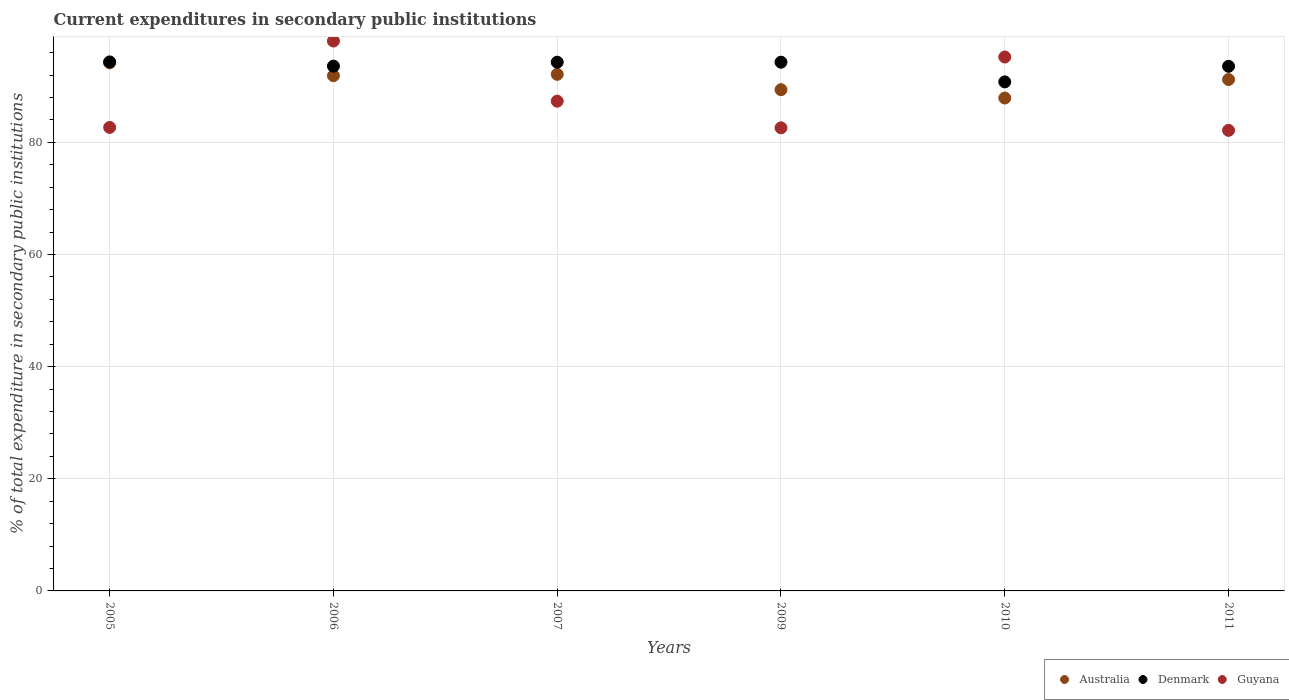How many different coloured dotlines are there?
Ensure brevity in your answer.  3. What is the current expenditures in secondary public institutions in Guyana in 2006?
Your response must be concise. 98.07. Across all years, what is the maximum current expenditures in secondary public institutions in Australia?
Offer a very short reply. 94.19. Across all years, what is the minimum current expenditures in secondary public institutions in Denmark?
Offer a very short reply. 90.79. In which year was the current expenditures in secondary public institutions in Guyana minimum?
Ensure brevity in your answer.  2011. What is the total current expenditures in secondary public institutions in Denmark in the graph?
Provide a short and direct response. 560.88. What is the difference between the current expenditures in secondary public institutions in Guyana in 2005 and that in 2007?
Give a very brief answer. -4.68. What is the difference between the current expenditures in secondary public institutions in Australia in 2007 and the current expenditures in secondary public institutions in Guyana in 2010?
Your response must be concise. -3.09. What is the average current expenditures in secondary public institutions in Guyana per year?
Keep it short and to the point. 88. In the year 2006, what is the difference between the current expenditures in secondary public institutions in Australia and current expenditures in secondary public institutions in Guyana?
Keep it short and to the point. -6.18. What is the ratio of the current expenditures in secondary public institutions in Australia in 2005 to that in 2010?
Offer a terse response. 1.07. Is the difference between the current expenditures in secondary public institutions in Australia in 2005 and 2011 greater than the difference between the current expenditures in secondary public institutions in Guyana in 2005 and 2011?
Provide a succinct answer. Yes. What is the difference between the highest and the second highest current expenditures in secondary public institutions in Guyana?
Ensure brevity in your answer.  2.85. What is the difference between the highest and the lowest current expenditures in secondary public institutions in Australia?
Your answer should be compact. 6.29. In how many years, is the current expenditures in secondary public institutions in Guyana greater than the average current expenditures in secondary public institutions in Guyana taken over all years?
Your answer should be compact. 2. Does the current expenditures in secondary public institutions in Australia monotonically increase over the years?
Keep it short and to the point. No. Is the current expenditures in secondary public institutions in Australia strictly greater than the current expenditures in secondary public institutions in Denmark over the years?
Ensure brevity in your answer.  No. How many years are there in the graph?
Give a very brief answer. 6. What is the difference between two consecutive major ticks on the Y-axis?
Provide a short and direct response. 20. Does the graph contain any zero values?
Ensure brevity in your answer.  No. What is the title of the graph?
Offer a very short reply. Current expenditures in secondary public institutions. Does "Middle East & North Africa (developing only)" appear as one of the legend labels in the graph?
Offer a terse response. No. What is the label or title of the Y-axis?
Your answer should be very brief. % of total expenditure in secondary public institutions. What is the % of total expenditure in secondary public institutions of Australia in 2005?
Provide a succinct answer. 94.19. What is the % of total expenditure in secondary public institutions of Denmark in 2005?
Provide a succinct answer. 94.35. What is the % of total expenditure in secondary public institutions of Guyana in 2005?
Offer a very short reply. 82.66. What is the % of total expenditure in secondary public institutions of Australia in 2006?
Your response must be concise. 91.89. What is the % of total expenditure in secondary public institutions of Denmark in 2006?
Your answer should be very brief. 93.59. What is the % of total expenditure in secondary public institutions of Guyana in 2006?
Make the answer very short. 98.07. What is the % of total expenditure in secondary public institutions of Australia in 2007?
Offer a very short reply. 92.13. What is the % of total expenditure in secondary public institutions in Denmark in 2007?
Provide a succinct answer. 94.3. What is the % of total expenditure in secondary public institutions of Guyana in 2007?
Your answer should be compact. 87.35. What is the % of total expenditure in secondary public institutions in Australia in 2009?
Offer a terse response. 89.39. What is the % of total expenditure in secondary public institutions in Denmark in 2009?
Provide a succinct answer. 94.3. What is the % of total expenditure in secondary public institutions of Guyana in 2009?
Give a very brief answer. 82.59. What is the % of total expenditure in secondary public institutions of Australia in 2010?
Your response must be concise. 87.91. What is the % of total expenditure in secondary public institutions of Denmark in 2010?
Provide a succinct answer. 90.79. What is the % of total expenditure in secondary public institutions in Guyana in 2010?
Make the answer very short. 95.22. What is the % of total expenditure in secondary public institutions of Australia in 2011?
Offer a terse response. 91.2. What is the % of total expenditure in secondary public institutions in Denmark in 2011?
Provide a short and direct response. 93.56. What is the % of total expenditure in secondary public institutions in Guyana in 2011?
Ensure brevity in your answer.  82.14. Across all years, what is the maximum % of total expenditure in secondary public institutions of Australia?
Provide a succinct answer. 94.19. Across all years, what is the maximum % of total expenditure in secondary public institutions in Denmark?
Your answer should be very brief. 94.35. Across all years, what is the maximum % of total expenditure in secondary public institutions of Guyana?
Offer a terse response. 98.07. Across all years, what is the minimum % of total expenditure in secondary public institutions of Australia?
Your response must be concise. 87.91. Across all years, what is the minimum % of total expenditure in secondary public institutions of Denmark?
Provide a succinct answer. 90.79. Across all years, what is the minimum % of total expenditure in secondary public institutions of Guyana?
Your answer should be very brief. 82.14. What is the total % of total expenditure in secondary public institutions of Australia in the graph?
Your response must be concise. 546.71. What is the total % of total expenditure in secondary public institutions of Denmark in the graph?
Your response must be concise. 560.88. What is the total % of total expenditure in secondary public institutions in Guyana in the graph?
Provide a succinct answer. 528.03. What is the difference between the % of total expenditure in secondary public institutions in Australia in 2005 and that in 2006?
Offer a terse response. 2.3. What is the difference between the % of total expenditure in secondary public institutions of Denmark in 2005 and that in 2006?
Offer a very short reply. 0.75. What is the difference between the % of total expenditure in secondary public institutions of Guyana in 2005 and that in 2006?
Give a very brief answer. -15.41. What is the difference between the % of total expenditure in secondary public institutions of Australia in 2005 and that in 2007?
Your response must be concise. 2.06. What is the difference between the % of total expenditure in secondary public institutions of Denmark in 2005 and that in 2007?
Give a very brief answer. 0.05. What is the difference between the % of total expenditure in secondary public institutions in Guyana in 2005 and that in 2007?
Your answer should be compact. -4.68. What is the difference between the % of total expenditure in secondary public institutions of Australia in 2005 and that in 2009?
Your answer should be compact. 4.8. What is the difference between the % of total expenditure in secondary public institutions of Denmark in 2005 and that in 2009?
Provide a succinct answer. 0.05. What is the difference between the % of total expenditure in secondary public institutions of Guyana in 2005 and that in 2009?
Keep it short and to the point. 0.07. What is the difference between the % of total expenditure in secondary public institutions in Australia in 2005 and that in 2010?
Provide a short and direct response. 6.29. What is the difference between the % of total expenditure in secondary public institutions of Denmark in 2005 and that in 2010?
Provide a succinct answer. 3.56. What is the difference between the % of total expenditure in secondary public institutions in Guyana in 2005 and that in 2010?
Your answer should be compact. -12.56. What is the difference between the % of total expenditure in secondary public institutions in Australia in 2005 and that in 2011?
Keep it short and to the point. 2.99. What is the difference between the % of total expenditure in secondary public institutions in Denmark in 2005 and that in 2011?
Make the answer very short. 0.79. What is the difference between the % of total expenditure in secondary public institutions in Guyana in 2005 and that in 2011?
Provide a succinct answer. 0.52. What is the difference between the % of total expenditure in secondary public institutions in Australia in 2006 and that in 2007?
Give a very brief answer. -0.24. What is the difference between the % of total expenditure in secondary public institutions in Denmark in 2006 and that in 2007?
Your answer should be very brief. -0.7. What is the difference between the % of total expenditure in secondary public institutions of Guyana in 2006 and that in 2007?
Your response must be concise. 10.72. What is the difference between the % of total expenditure in secondary public institutions of Australia in 2006 and that in 2009?
Provide a short and direct response. 2.5. What is the difference between the % of total expenditure in secondary public institutions of Denmark in 2006 and that in 2009?
Your answer should be compact. -0.7. What is the difference between the % of total expenditure in secondary public institutions of Guyana in 2006 and that in 2009?
Ensure brevity in your answer.  15.48. What is the difference between the % of total expenditure in secondary public institutions of Australia in 2006 and that in 2010?
Offer a very short reply. 3.99. What is the difference between the % of total expenditure in secondary public institutions in Denmark in 2006 and that in 2010?
Provide a succinct answer. 2.81. What is the difference between the % of total expenditure in secondary public institutions of Guyana in 2006 and that in 2010?
Your answer should be very brief. 2.85. What is the difference between the % of total expenditure in secondary public institutions in Australia in 2006 and that in 2011?
Give a very brief answer. 0.69. What is the difference between the % of total expenditure in secondary public institutions of Denmark in 2006 and that in 2011?
Your answer should be compact. 0.03. What is the difference between the % of total expenditure in secondary public institutions of Guyana in 2006 and that in 2011?
Your response must be concise. 15.93. What is the difference between the % of total expenditure in secondary public institutions of Australia in 2007 and that in 2009?
Ensure brevity in your answer.  2.74. What is the difference between the % of total expenditure in secondary public institutions in Denmark in 2007 and that in 2009?
Offer a terse response. -0. What is the difference between the % of total expenditure in secondary public institutions in Guyana in 2007 and that in 2009?
Give a very brief answer. 4.76. What is the difference between the % of total expenditure in secondary public institutions of Australia in 2007 and that in 2010?
Your answer should be very brief. 4.23. What is the difference between the % of total expenditure in secondary public institutions of Denmark in 2007 and that in 2010?
Keep it short and to the point. 3.51. What is the difference between the % of total expenditure in secondary public institutions of Guyana in 2007 and that in 2010?
Provide a short and direct response. -7.87. What is the difference between the % of total expenditure in secondary public institutions of Australia in 2007 and that in 2011?
Your response must be concise. 0.93. What is the difference between the % of total expenditure in secondary public institutions of Denmark in 2007 and that in 2011?
Your response must be concise. 0.73. What is the difference between the % of total expenditure in secondary public institutions in Guyana in 2007 and that in 2011?
Your response must be concise. 5.21. What is the difference between the % of total expenditure in secondary public institutions of Australia in 2009 and that in 2010?
Keep it short and to the point. 1.49. What is the difference between the % of total expenditure in secondary public institutions of Denmark in 2009 and that in 2010?
Your answer should be compact. 3.51. What is the difference between the % of total expenditure in secondary public institutions of Guyana in 2009 and that in 2010?
Provide a succinct answer. -12.63. What is the difference between the % of total expenditure in secondary public institutions of Australia in 2009 and that in 2011?
Provide a succinct answer. -1.81. What is the difference between the % of total expenditure in secondary public institutions in Denmark in 2009 and that in 2011?
Provide a succinct answer. 0.74. What is the difference between the % of total expenditure in secondary public institutions of Guyana in 2009 and that in 2011?
Your answer should be very brief. 0.45. What is the difference between the % of total expenditure in secondary public institutions in Australia in 2010 and that in 2011?
Your answer should be very brief. -3.3. What is the difference between the % of total expenditure in secondary public institutions in Denmark in 2010 and that in 2011?
Your response must be concise. -2.77. What is the difference between the % of total expenditure in secondary public institutions in Guyana in 2010 and that in 2011?
Give a very brief answer. 13.08. What is the difference between the % of total expenditure in secondary public institutions in Australia in 2005 and the % of total expenditure in secondary public institutions in Denmark in 2006?
Ensure brevity in your answer.  0.6. What is the difference between the % of total expenditure in secondary public institutions in Australia in 2005 and the % of total expenditure in secondary public institutions in Guyana in 2006?
Give a very brief answer. -3.88. What is the difference between the % of total expenditure in secondary public institutions of Denmark in 2005 and the % of total expenditure in secondary public institutions of Guyana in 2006?
Provide a short and direct response. -3.72. What is the difference between the % of total expenditure in secondary public institutions in Australia in 2005 and the % of total expenditure in secondary public institutions in Denmark in 2007?
Keep it short and to the point. -0.11. What is the difference between the % of total expenditure in secondary public institutions of Australia in 2005 and the % of total expenditure in secondary public institutions of Guyana in 2007?
Offer a terse response. 6.84. What is the difference between the % of total expenditure in secondary public institutions in Denmark in 2005 and the % of total expenditure in secondary public institutions in Guyana in 2007?
Offer a very short reply. 7. What is the difference between the % of total expenditure in secondary public institutions of Australia in 2005 and the % of total expenditure in secondary public institutions of Denmark in 2009?
Provide a short and direct response. -0.11. What is the difference between the % of total expenditure in secondary public institutions of Australia in 2005 and the % of total expenditure in secondary public institutions of Guyana in 2009?
Ensure brevity in your answer.  11.6. What is the difference between the % of total expenditure in secondary public institutions in Denmark in 2005 and the % of total expenditure in secondary public institutions in Guyana in 2009?
Provide a short and direct response. 11.76. What is the difference between the % of total expenditure in secondary public institutions of Australia in 2005 and the % of total expenditure in secondary public institutions of Denmark in 2010?
Provide a succinct answer. 3.4. What is the difference between the % of total expenditure in secondary public institutions in Australia in 2005 and the % of total expenditure in secondary public institutions in Guyana in 2010?
Provide a short and direct response. -1.03. What is the difference between the % of total expenditure in secondary public institutions of Denmark in 2005 and the % of total expenditure in secondary public institutions of Guyana in 2010?
Give a very brief answer. -0.87. What is the difference between the % of total expenditure in secondary public institutions of Australia in 2005 and the % of total expenditure in secondary public institutions of Denmark in 2011?
Keep it short and to the point. 0.63. What is the difference between the % of total expenditure in secondary public institutions of Australia in 2005 and the % of total expenditure in secondary public institutions of Guyana in 2011?
Provide a succinct answer. 12.05. What is the difference between the % of total expenditure in secondary public institutions of Denmark in 2005 and the % of total expenditure in secondary public institutions of Guyana in 2011?
Provide a succinct answer. 12.21. What is the difference between the % of total expenditure in secondary public institutions in Australia in 2006 and the % of total expenditure in secondary public institutions in Denmark in 2007?
Provide a short and direct response. -2.4. What is the difference between the % of total expenditure in secondary public institutions of Australia in 2006 and the % of total expenditure in secondary public institutions of Guyana in 2007?
Offer a very short reply. 4.55. What is the difference between the % of total expenditure in secondary public institutions in Denmark in 2006 and the % of total expenditure in secondary public institutions in Guyana in 2007?
Make the answer very short. 6.25. What is the difference between the % of total expenditure in secondary public institutions in Australia in 2006 and the % of total expenditure in secondary public institutions in Denmark in 2009?
Provide a short and direct response. -2.4. What is the difference between the % of total expenditure in secondary public institutions of Australia in 2006 and the % of total expenditure in secondary public institutions of Guyana in 2009?
Your answer should be very brief. 9.3. What is the difference between the % of total expenditure in secondary public institutions in Denmark in 2006 and the % of total expenditure in secondary public institutions in Guyana in 2009?
Your answer should be very brief. 11. What is the difference between the % of total expenditure in secondary public institutions of Australia in 2006 and the % of total expenditure in secondary public institutions of Denmark in 2010?
Offer a terse response. 1.1. What is the difference between the % of total expenditure in secondary public institutions of Australia in 2006 and the % of total expenditure in secondary public institutions of Guyana in 2010?
Offer a terse response. -3.33. What is the difference between the % of total expenditure in secondary public institutions in Denmark in 2006 and the % of total expenditure in secondary public institutions in Guyana in 2010?
Keep it short and to the point. -1.63. What is the difference between the % of total expenditure in secondary public institutions of Australia in 2006 and the % of total expenditure in secondary public institutions of Denmark in 2011?
Your answer should be very brief. -1.67. What is the difference between the % of total expenditure in secondary public institutions of Australia in 2006 and the % of total expenditure in secondary public institutions of Guyana in 2011?
Provide a succinct answer. 9.75. What is the difference between the % of total expenditure in secondary public institutions in Denmark in 2006 and the % of total expenditure in secondary public institutions in Guyana in 2011?
Give a very brief answer. 11.45. What is the difference between the % of total expenditure in secondary public institutions in Australia in 2007 and the % of total expenditure in secondary public institutions in Denmark in 2009?
Your answer should be compact. -2.17. What is the difference between the % of total expenditure in secondary public institutions in Australia in 2007 and the % of total expenditure in secondary public institutions in Guyana in 2009?
Provide a short and direct response. 9.54. What is the difference between the % of total expenditure in secondary public institutions in Denmark in 2007 and the % of total expenditure in secondary public institutions in Guyana in 2009?
Your answer should be very brief. 11.7. What is the difference between the % of total expenditure in secondary public institutions of Australia in 2007 and the % of total expenditure in secondary public institutions of Denmark in 2010?
Provide a succinct answer. 1.34. What is the difference between the % of total expenditure in secondary public institutions of Australia in 2007 and the % of total expenditure in secondary public institutions of Guyana in 2010?
Your answer should be compact. -3.09. What is the difference between the % of total expenditure in secondary public institutions in Denmark in 2007 and the % of total expenditure in secondary public institutions in Guyana in 2010?
Keep it short and to the point. -0.93. What is the difference between the % of total expenditure in secondary public institutions in Australia in 2007 and the % of total expenditure in secondary public institutions in Denmark in 2011?
Your answer should be compact. -1.43. What is the difference between the % of total expenditure in secondary public institutions in Australia in 2007 and the % of total expenditure in secondary public institutions in Guyana in 2011?
Ensure brevity in your answer.  9.99. What is the difference between the % of total expenditure in secondary public institutions of Denmark in 2007 and the % of total expenditure in secondary public institutions of Guyana in 2011?
Keep it short and to the point. 12.16. What is the difference between the % of total expenditure in secondary public institutions in Australia in 2009 and the % of total expenditure in secondary public institutions in Denmark in 2010?
Offer a terse response. -1.4. What is the difference between the % of total expenditure in secondary public institutions in Australia in 2009 and the % of total expenditure in secondary public institutions in Guyana in 2010?
Make the answer very short. -5.83. What is the difference between the % of total expenditure in secondary public institutions of Denmark in 2009 and the % of total expenditure in secondary public institutions of Guyana in 2010?
Your answer should be compact. -0.92. What is the difference between the % of total expenditure in secondary public institutions in Australia in 2009 and the % of total expenditure in secondary public institutions in Denmark in 2011?
Keep it short and to the point. -4.17. What is the difference between the % of total expenditure in secondary public institutions in Australia in 2009 and the % of total expenditure in secondary public institutions in Guyana in 2011?
Ensure brevity in your answer.  7.25. What is the difference between the % of total expenditure in secondary public institutions of Denmark in 2009 and the % of total expenditure in secondary public institutions of Guyana in 2011?
Your answer should be very brief. 12.16. What is the difference between the % of total expenditure in secondary public institutions in Australia in 2010 and the % of total expenditure in secondary public institutions in Denmark in 2011?
Provide a short and direct response. -5.66. What is the difference between the % of total expenditure in secondary public institutions in Australia in 2010 and the % of total expenditure in secondary public institutions in Guyana in 2011?
Give a very brief answer. 5.77. What is the difference between the % of total expenditure in secondary public institutions in Denmark in 2010 and the % of total expenditure in secondary public institutions in Guyana in 2011?
Offer a terse response. 8.65. What is the average % of total expenditure in secondary public institutions of Australia per year?
Your answer should be compact. 91.12. What is the average % of total expenditure in secondary public institutions in Denmark per year?
Offer a very short reply. 93.48. What is the average % of total expenditure in secondary public institutions in Guyana per year?
Give a very brief answer. 88. In the year 2005, what is the difference between the % of total expenditure in secondary public institutions in Australia and % of total expenditure in secondary public institutions in Denmark?
Provide a short and direct response. -0.16. In the year 2005, what is the difference between the % of total expenditure in secondary public institutions of Australia and % of total expenditure in secondary public institutions of Guyana?
Your answer should be compact. 11.53. In the year 2005, what is the difference between the % of total expenditure in secondary public institutions of Denmark and % of total expenditure in secondary public institutions of Guyana?
Make the answer very short. 11.69. In the year 2006, what is the difference between the % of total expenditure in secondary public institutions in Australia and % of total expenditure in secondary public institutions in Denmark?
Offer a terse response. -1.7. In the year 2006, what is the difference between the % of total expenditure in secondary public institutions of Australia and % of total expenditure in secondary public institutions of Guyana?
Offer a very short reply. -6.18. In the year 2006, what is the difference between the % of total expenditure in secondary public institutions of Denmark and % of total expenditure in secondary public institutions of Guyana?
Your answer should be very brief. -4.48. In the year 2007, what is the difference between the % of total expenditure in secondary public institutions in Australia and % of total expenditure in secondary public institutions in Denmark?
Provide a succinct answer. -2.16. In the year 2007, what is the difference between the % of total expenditure in secondary public institutions of Australia and % of total expenditure in secondary public institutions of Guyana?
Provide a short and direct response. 4.78. In the year 2007, what is the difference between the % of total expenditure in secondary public institutions of Denmark and % of total expenditure in secondary public institutions of Guyana?
Offer a very short reply. 6.95. In the year 2009, what is the difference between the % of total expenditure in secondary public institutions of Australia and % of total expenditure in secondary public institutions of Denmark?
Provide a short and direct response. -4.91. In the year 2009, what is the difference between the % of total expenditure in secondary public institutions in Australia and % of total expenditure in secondary public institutions in Guyana?
Ensure brevity in your answer.  6.8. In the year 2009, what is the difference between the % of total expenditure in secondary public institutions in Denmark and % of total expenditure in secondary public institutions in Guyana?
Provide a short and direct response. 11.71. In the year 2010, what is the difference between the % of total expenditure in secondary public institutions in Australia and % of total expenditure in secondary public institutions in Denmark?
Your answer should be compact. -2.88. In the year 2010, what is the difference between the % of total expenditure in secondary public institutions of Australia and % of total expenditure in secondary public institutions of Guyana?
Keep it short and to the point. -7.32. In the year 2010, what is the difference between the % of total expenditure in secondary public institutions of Denmark and % of total expenditure in secondary public institutions of Guyana?
Your answer should be compact. -4.43. In the year 2011, what is the difference between the % of total expenditure in secondary public institutions in Australia and % of total expenditure in secondary public institutions in Denmark?
Keep it short and to the point. -2.36. In the year 2011, what is the difference between the % of total expenditure in secondary public institutions of Australia and % of total expenditure in secondary public institutions of Guyana?
Your response must be concise. 9.06. In the year 2011, what is the difference between the % of total expenditure in secondary public institutions in Denmark and % of total expenditure in secondary public institutions in Guyana?
Your answer should be compact. 11.42. What is the ratio of the % of total expenditure in secondary public institutions in Australia in 2005 to that in 2006?
Offer a very short reply. 1.02. What is the ratio of the % of total expenditure in secondary public institutions in Denmark in 2005 to that in 2006?
Make the answer very short. 1.01. What is the ratio of the % of total expenditure in secondary public institutions of Guyana in 2005 to that in 2006?
Your answer should be compact. 0.84. What is the ratio of the % of total expenditure in secondary public institutions in Australia in 2005 to that in 2007?
Make the answer very short. 1.02. What is the ratio of the % of total expenditure in secondary public institutions in Denmark in 2005 to that in 2007?
Provide a short and direct response. 1. What is the ratio of the % of total expenditure in secondary public institutions of Guyana in 2005 to that in 2007?
Give a very brief answer. 0.95. What is the ratio of the % of total expenditure in secondary public institutions of Australia in 2005 to that in 2009?
Make the answer very short. 1.05. What is the ratio of the % of total expenditure in secondary public institutions in Denmark in 2005 to that in 2009?
Offer a very short reply. 1. What is the ratio of the % of total expenditure in secondary public institutions of Australia in 2005 to that in 2010?
Your answer should be compact. 1.07. What is the ratio of the % of total expenditure in secondary public institutions in Denmark in 2005 to that in 2010?
Your answer should be very brief. 1.04. What is the ratio of the % of total expenditure in secondary public institutions in Guyana in 2005 to that in 2010?
Ensure brevity in your answer.  0.87. What is the ratio of the % of total expenditure in secondary public institutions in Australia in 2005 to that in 2011?
Provide a short and direct response. 1.03. What is the ratio of the % of total expenditure in secondary public institutions in Denmark in 2005 to that in 2011?
Provide a succinct answer. 1.01. What is the ratio of the % of total expenditure in secondary public institutions of Guyana in 2005 to that in 2011?
Your answer should be very brief. 1.01. What is the ratio of the % of total expenditure in secondary public institutions in Guyana in 2006 to that in 2007?
Your answer should be compact. 1.12. What is the ratio of the % of total expenditure in secondary public institutions of Australia in 2006 to that in 2009?
Provide a short and direct response. 1.03. What is the ratio of the % of total expenditure in secondary public institutions in Guyana in 2006 to that in 2009?
Offer a terse response. 1.19. What is the ratio of the % of total expenditure in secondary public institutions of Australia in 2006 to that in 2010?
Your answer should be compact. 1.05. What is the ratio of the % of total expenditure in secondary public institutions in Denmark in 2006 to that in 2010?
Keep it short and to the point. 1.03. What is the ratio of the % of total expenditure in secondary public institutions in Guyana in 2006 to that in 2010?
Keep it short and to the point. 1.03. What is the ratio of the % of total expenditure in secondary public institutions in Australia in 2006 to that in 2011?
Offer a terse response. 1.01. What is the ratio of the % of total expenditure in secondary public institutions of Denmark in 2006 to that in 2011?
Offer a terse response. 1. What is the ratio of the % of total expenditure in secondary public institutions of Guyana in 2006 to that in 2011?
Your answer should be compact. 1.19. What is the ratio of the % of total expenditure in secondary public institutions in Australia in 2007 to that in 2009?
Your answer should be very brief. 1.03. What is the ratio of the % of total expenditure in secondary public institutions in Denmark in 2007 to that in 2009?
Keep it short and to the point. 1. What is the ratio of the % of total expenditure in secondary public institutions of Guyana in 2007 to that in 2009?
Offer a terse response. 1.06. What is the ratio of the % of total expenditure in secondary public institutions in Australia in 2007 to that in 2010?
Provide a succinct answer. 1.05. What is the ratio of the % of total expenditure in secondary public institutions of Denmark in 2007 to that in 2010?
Provide a succinct answer. 1.04. What is the ratio of the % of total expenditure in secondary public institutions of Guyana in 2007 to that in 2010?
Your answer should be very brief. 0.92. What is the ratio of the % of total expenditure in secondary public institutions of Australia in 2007 to that in 2011?
Your response must be concise. 1.01. What is the ratio of the % of total expenditure in secondary public institutions of Guyana in 2007 to that in 2011?
Keep it short and to the point. 1.06. What is the ratio of the % of total expenditure in secondary public institutions in Australia in 2009 to that in 2010?
Provide a succinct answer. 1.02. What is the ratio of the % of total expenditure in secondary public institutions of Denmark in 2009 to that in 2010?
Your answer should be compact. 1.04. What is the ratio of the % of total expenditure in secondary public institutions in Guyana in 2009 to that in 2010?
Make the answer very short. 0.87. What is the ratio of the % of total expenditure in secondary public institutions of Australia in 2009 to that in 2011?
Your response must be concise. 0.98. What is the ratio of the % of total expenditure in secondary public institutions in Denmark in 2009 to that in 2011?
Your response must be concise. 1.01. What is the ratio of the % of total expenditure in secondary public institutions in Guyana in 2009 to that in 2011?
Your answer should be compact. 1.01. What is the ratio of the % of total expenditure in secondary public institutions of Australia in 2010 to that in 2011?
Provide a short and direct response. 0.96. What is the ratio of the % of total expenditure in secondary public institutions of Denmark in 2010 to that in 2011?
Make the answer very short. 0.97. What is the ratio of the % of total expenditure in secondary public institutions in Guyana in 2010 to that in 2011?
Provide a succinct answer. 1.16. What is the difference between the highest and the second highest % of total expenditure in secondary public institutions of Australia?
Provide a short and direct response. 2.06. What is the difference between the highest and the second highest % of total expenditure in secondary public institutions in Denmark?
Provide a succinct answer. 0.05. What is the difference between the highest and the second highest % of total expenditure in secondary public institutions of Guyana?
Your response must be concise. 2.85. What is the difference between the highest and the lowest % of total expenditure in secondary public institutions in Australia?
Provide a succinct answer. 6.29. What is the difference between the highest and the lowest % of total expenditure in secondary public institutions of Denmark?
Give a very brief answer. 3.56. What is the difference between the highest and the lowest % of total expenditure in secondary public institutions in Guyana?
Keep it short and to the point. 15.93. 